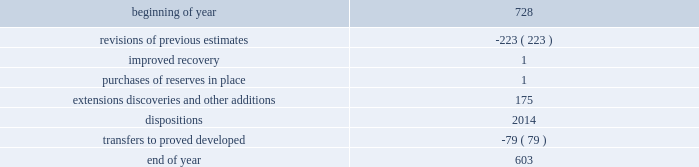During 2015 , 2014 and 2013 , netherland , sewell & associates , inc .
( "nsai" ) prepared a certification of the prior year's reserves for the alba field in e.g .
The nsai summary reports are filed as an exhibit to this annual report on form 10-k .
Members of the nsai team have multiple years of industry experience , having worked for large , international oil and gas companies before joining nsai .
The senior technical advisor has over 35 years of practical experience in petroleum geosciences , with over 15 years experience in the estimation and evaluation of reserves .
The second team member has over 10 years of practical experience in petroleum engineering , with over five years experience in the estimation and evaluation of reserves .
Both are registered professional engineers in the state of texas .
Ryder scott company ( "ryder scott" ) also performed audits of the prior years' reserves of several of our fields in 2015 , 2014 and 2013 .
Their summary reports are filed as exhibits to this annual report on form 10-k .
The team lead for ryder scott has over 20 years of industry experience , having worked for a major international oil and gas company before joining ryder scott .
He is a member of spe , where he served on the oil and gas reserves committee , and is a registered professional engineer in the state of texas .
Changes in proved undeveloped reserves as of december 31 , 2015 , 603 mmboe of proved undeveloped reserves were reported , a decrease of 125 mmboe from december 31 , 2014 .
The table shows changes in total proved undeveloped reserves for 2015 : ( mmboe ) .
The revisions to previous estimates were largely due to a result of reductions to our capital development program which deferred proved undeveloped reserves beyond the 5-year plan .
A total of 139 mmboe was booked as extensions , discoveries or other additions and revisions due to the application of reliable technology .
Technologies included statistical analysis of production performance , decline curve analysis , pressure and rate transient analysis , reservoir simulation and volumetric analysis .
The observed statistical nature of production performance coupled with highly certain reservoir continuity or quality within the reliable technology areas and sufficient proved developed locations establish the reasonable certainty criteria required for booking proved reserves .
Transfers from proved undeveloped to proved developed reserves included 47 mmboe in the eagle ford , 14 mmboe in the bakken and 5 mmboe in the oklahoma resource basins due to development drilling and completions .
Costs incurred in 2015 , 2014 and 2013 relating to the development of proved undeveloped reserves were $ 1415 million , $ 3149 million and $ 2536 million .
Projects can remain in proved undeveloped reserves for extended periods in certain situations such as large development projects which take more than five years to complete , or the timing of when additional gas compression is needed .
Of the 603 mmboe of proved undeveloped reserves at december 31 , 2015 , 26% ( 26 % ) of the volume is associated with projects that have been included in proved reserves for more than five years .
The majority of this volume is related to a compression project in e.g .
That was sanctioned by our board of directors in 2004 .
During 2012 , the compression project received the approval of the e.g .
Government , fabrication of the new platform began in 2013 and installation of the platform at the alba field occurred in january 2016 .
Commissioning is currently underway , with first production expected by mid-2016 .
Proved undeveloped reserves for the north gialo development , located in the libyan sahara desert , were booked for the first time in 2010 .
This development is being executed by the operator and encompasses a multi-year drilling program including the design , fabrication and installation of extensive liquid handling and gas recycling facilities .
Anecdotal evidence from similar development projects in the region leads to an expected project execution time frame of more than five years from the time the reserves were initially booked .
Interruptions associated with the civil and political unrest have also extended the project duration .
Operations were interrupted in mid-2013 as a result of the shutdown of the es sider crude oil terminal , and although temporarily re-opened during the second half of 2014 , production remains shut-in through early 2016 .
The operator is committed to the project 2019s completion and continues to assign resources in order to execute the project .
Our conversion rate for proved undeveloped reserves to proved developed reserves for 2015 was 11% ( 11 % ) .
However , excluding the aforementioned long-term projects in e.g .
And libya , our 2015 conversion rate would be 15% ( 15 % ) .
Furthermore , our .
What was the percentage decrease in proved undeveloped reserves from 2014 to 2015? 
Computations: (125 / 728)
Answer: 0.1717. During 2015 , 2014 and 2013 , netherland , sewell & associates , inc .
( "nsai" ) prepared a certification of the prior year's reserves for the alba field in e.g .
The nsai summary reports are filed as an exhibit to this annual report on form 10-k .
Members of the nsai team have multiple years of industry experience , having worked for large , international oil and gas companies before joining nsai .
The senior technical advisor has over 35 years of practical experience in petroleum geosciences , with over 15 years experience in the estimation and evaluation of reserves .
The second team member has over 10 years of practical experience in petroleum engineering , with over five years experience in the estimation and evaluation of reserves .
Both are registered professional engineers in the state of texas .
Ryder scott company ( "ryder scott" ) also performed audits of the prior years' reserves of several of our fields in 2015 , 2014 and 2013 .
Their summary reports are filed as exhibits to this annual report on form 10-k .
The team lead for ryder scott has over 20 years of industry experience , having worked for a major international oil and gas company before joining ryder scott .
He is a member of spe , where he served on the oil and gas reserves committee , and is a registered professional engineer in the state of texas .
Changes in proved undeveloped reserves as of december 31 , 2015 , 603 mmboe of proved undeveloped reserves were reported , a decrease of 125 mmboe from december 31 , 2014 .
The table shows changes in total proved undeveloped reserves for 2015 : ( mmboe ) .
The revisions to previous estimates were largely due to a result of reductions to our capital development program which deferred proved undeveloped reserves beyond the 5-year plan .
A total of 139 mmboe was booked as extensions , discoveries or other additions and revisions due to the application of reliable technology .
Technologies included statistical analysis of production performance , decline curve analysis , pressure and rate transient analysis , reservoir simulation and volumetric analysis .
The observed statistical nature of production performance coupled with highly certain reservoir continuity or quality within the reliable technology areas and sufficient proved developed locations establish the reasonable certainty criteria required for booking proved reserves .
Transfers from proved undeveloped to proved developed reserves included 47 mmboe in the eagle ford , 14 mmboe in the bakken and 5 mmboe in the oklahoma resource basins due to development drilling and completions .
Costs incurred in 2015 , 2014 and 2013 relating to the development of proved undeveloped reserves were $ 1415 million , $ 3149 million and $ 2536 million .
Projects can remain in proved undeveloped reserves for extended periods in certain situations such as large development projects which take more than five years to complete , or the timing of when additional gas compression is needed .
Of the 603 mmboe of proved undeveloped reserves at december 31 , 2015 , 26% ( 26 % ) of the volume is associated with projects that have been included in proved reserves for more than five years .
The majority of this volume is related to a compression project in e.g .
That was sanctioned by our board of directors in 2004 .
During 2012 , the compression project received the approval of the e.g .
Government , fabrication of the new platform began in 2013 and installation of the platform at the alba field occurred in january 2016 .
Commissioning is currently underway , with first production expected by mid-2016 .
Proved undeveloped reserves for the north gialo development , located in the libyan sahara desert , were booked for the first time in 2010 .
This development is being executed by the operator and encompasses a multi-year drilling program including the design , fabrication and installation of extensive liquid handling and gas recycling facilities .
Anecdotal evidence from similar development projects in the region leads to an expected project execution time frame of more than five years from the time the reserves were initially booked .
Interruptions associated with the civil and political unrest have also extended the project duration .
Operations were interrupted in mid-2013 as a result of the shutdown of the es sider crude oil terminal , and although temporarily re-opened during the second half of 2014 , production remains shut-in through early 2016 .
The operator is committed to the project 2019s completion and continues to assign resources in order to execute the project .
Our conversion rate for proved undeveloped reserves to proved developed reserves for 2015 was 11% ( 11 % ) .
However , excluding the aforementioned long-term projects in e.g .
And libya , our 2015 conversion rate would be 15% ( 15 % ) .
Furthermore , our .
How many of the year end 2015 proved undeveloped reserves were converted to proved developed reserves? 
Computations: (603 * 11%)
Answer: 66.33. 